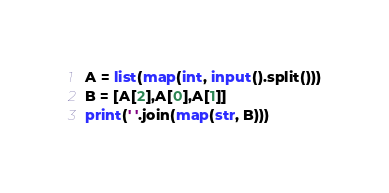<code> <loc_0><loc_0><loc_500><loc_500><_Python_>A = list(map(int, input().split()))
B = [A[2],A[0],A[1]]
print(' '.join(map(str, B)))</code> 